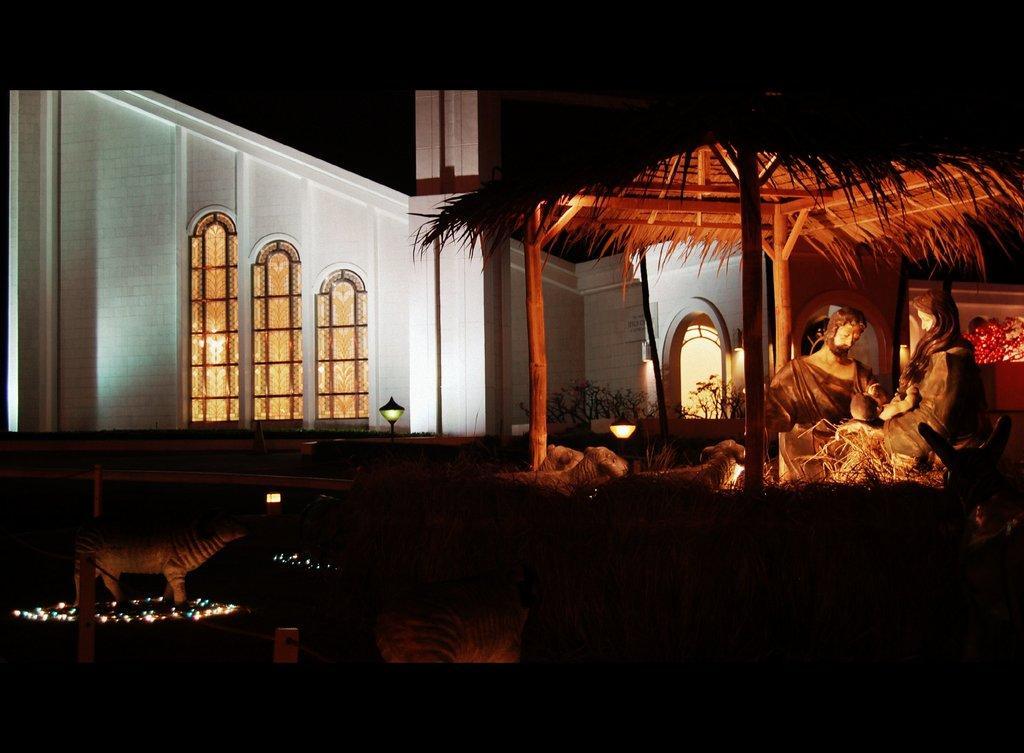Please provide a concise description of this image. In the image we can see some sculptures and hut. Behind the hut there is a building and lights. 